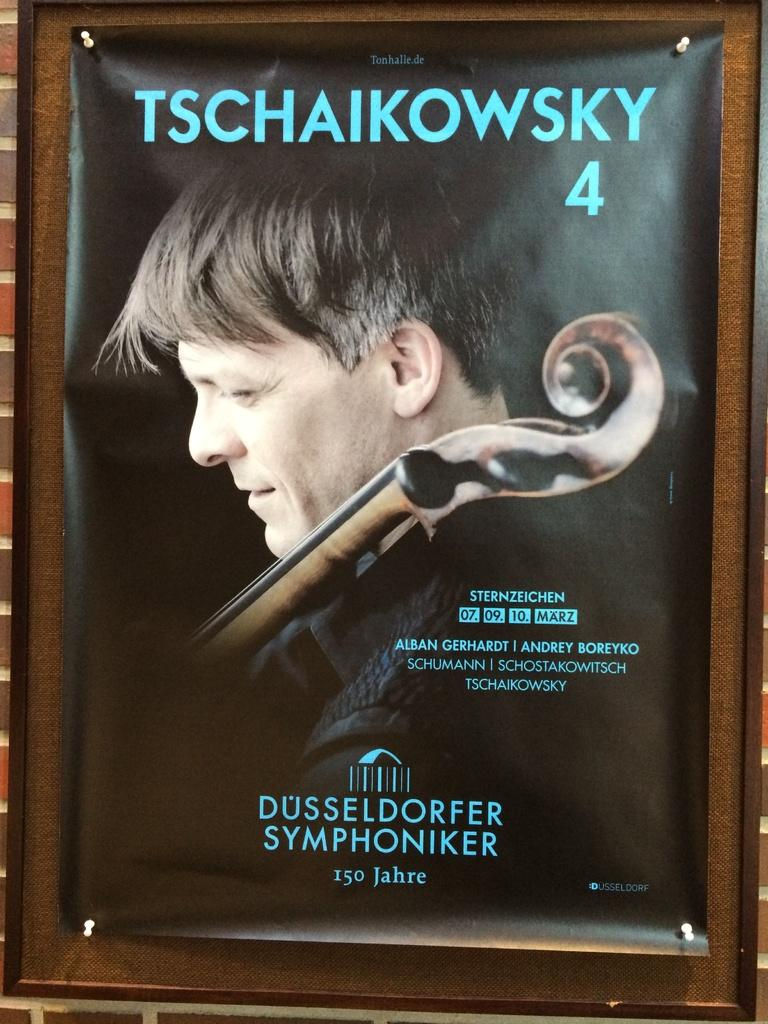What is present in the picture? There is a poster in the picture. What can be seen on the poster? There is a person depicted on the poster, along with pins and text. What type of rabbit can be seen playing with an appliance in the image? There is no rabbit or appliance present in the image; it only features a poster with a person, pins, and text. 